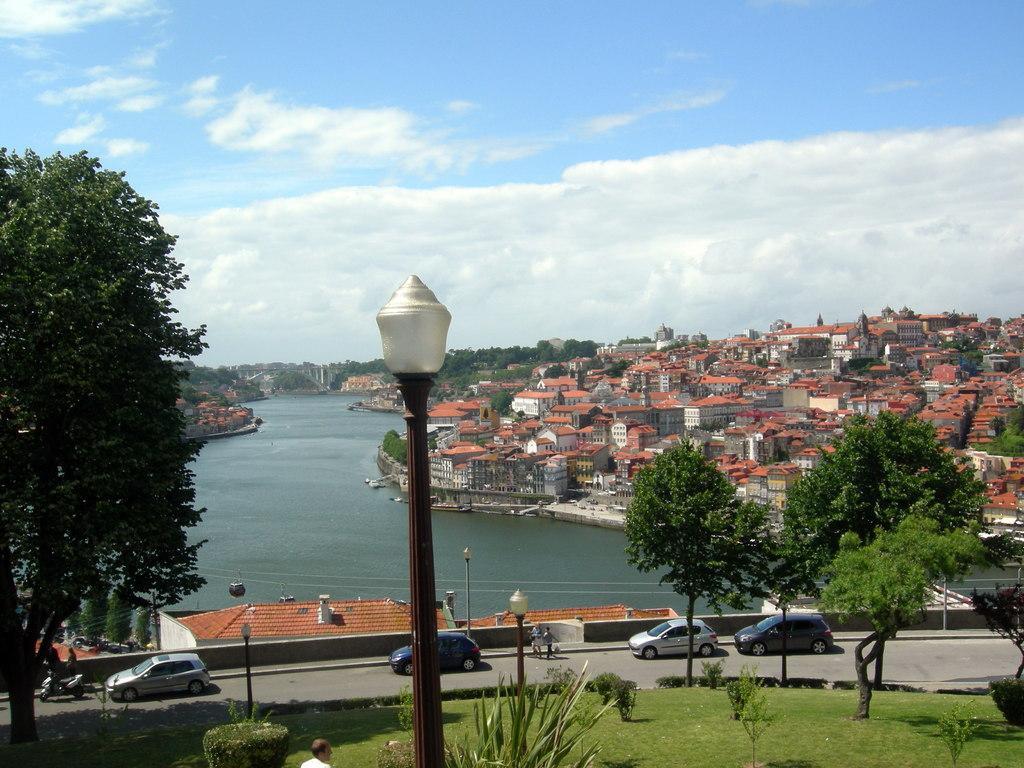In one or two sentences, can you explain what this image depicts? This is a top view of an area I can see buildings on the right side of the image I can see light poles, road and trees and garden in the center of the image towards the bottom and I can see a lake and at the top of the image I can see the sky.  